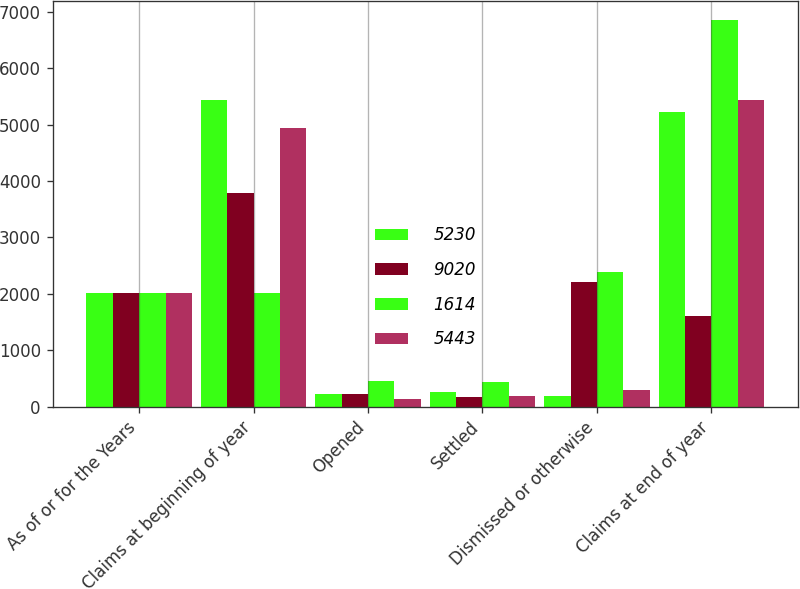Convert chart to OTSL. <chart><loc_0><loc_0><loc_500><loc_500><stacked_bar_chart><ecel><fcel>As of or for the Years<fcel>Claims at beginning of year<fcel>Opened<fcel>Settled<fcel>Dismissed or otherwise<fcel>Claims at end of year<nl><fcel>5230<fcel>2012<fcel>5443<fcel>226<fcel>254<fcel>185<fcel>5230<nl><fcel>9020<fcel>2012<fcel>3782<fcel>222<fcel>179<fcel>2211<fcel>1614<nl><fcel>1614<fcel>2012<fcel>2011<fcel>448<fcel>433<fcel>2396<fcel>6844<nl><fcel>5443<fcel>2011<fcel>4933<fcel>141<fcel>183<fcel>289<fcel>5443<nl></chart> 